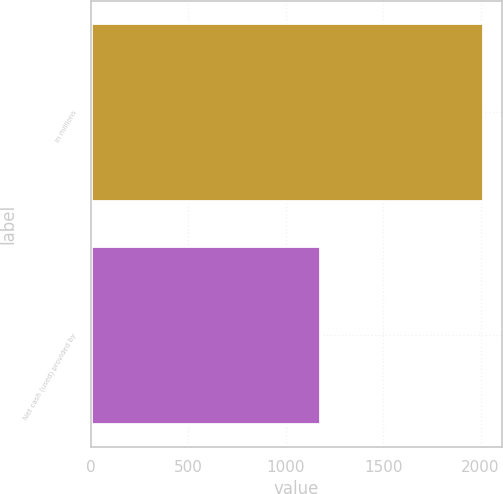Convert chart to OTSL. <chart><loc_0><loc_0><loc_500><loc_500><bar_chart><fcel>In millions<fcel>Net cash (used) provided by<nl><fcel>2011<fcel>1175<nl></chart> 